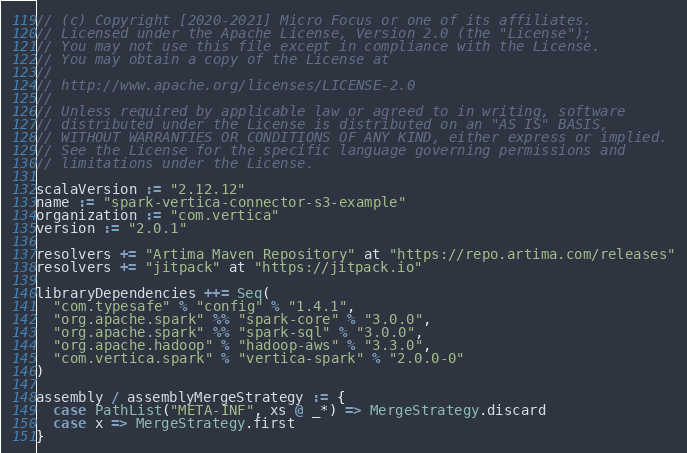Convert code to text. <code><loc_0><loc_0><loc_500><loc_500><_Scala_>// (c) Copyright [2020-2021] Micro Focus or one of its affiliates.
// Licensed under the Apache License, Version 2.0 (the "License");
// You may not use this file except in compliance with the License.
// You may obtain a copy of the License at
//
// http://www.apache.org/licenses/LICENSE-2.0
//
// Unless required by applicable law or agreed to in writing, software
// distributed under the License is distributed on an "AS IS" BASIS,
// WITHOUT WARRANTIES OR CONDITIONS OF ANY KIND, either express or implied.
// See the License for the specific language governing permissions and
// limitations under the License.

scalaVersion := "2.12.12"
name := "spark-vertica-connector-s3-example"
organization := "com.vertica"
version := "2.0.1"

resolvers += "Artima Maven Repository" at "https://repo.artima.com/releases"
resolvers += "jitpack" at "https://jitpack.io"

libraryDependencies ++= Seq(
  "com.typesafe" % "config" % "1.4.1",
  "org.apache.spark" %% "spark-core" % "3.0.0",
  "org.apache.spark" %% "spark-sql" % "3.0.0",
  "org.apache.hadoop" % "hadoop-aws" % "3.3.0",
  "com.vertica.spark" % "vertica-spark" % "2.0.0-0"
)

assembly / assemblyMergeStrategy := {
  case PathList("META-INF", xs @ _*) => MergeStrategy.discard
  case x => MergeStrategy.first
}
</code> 